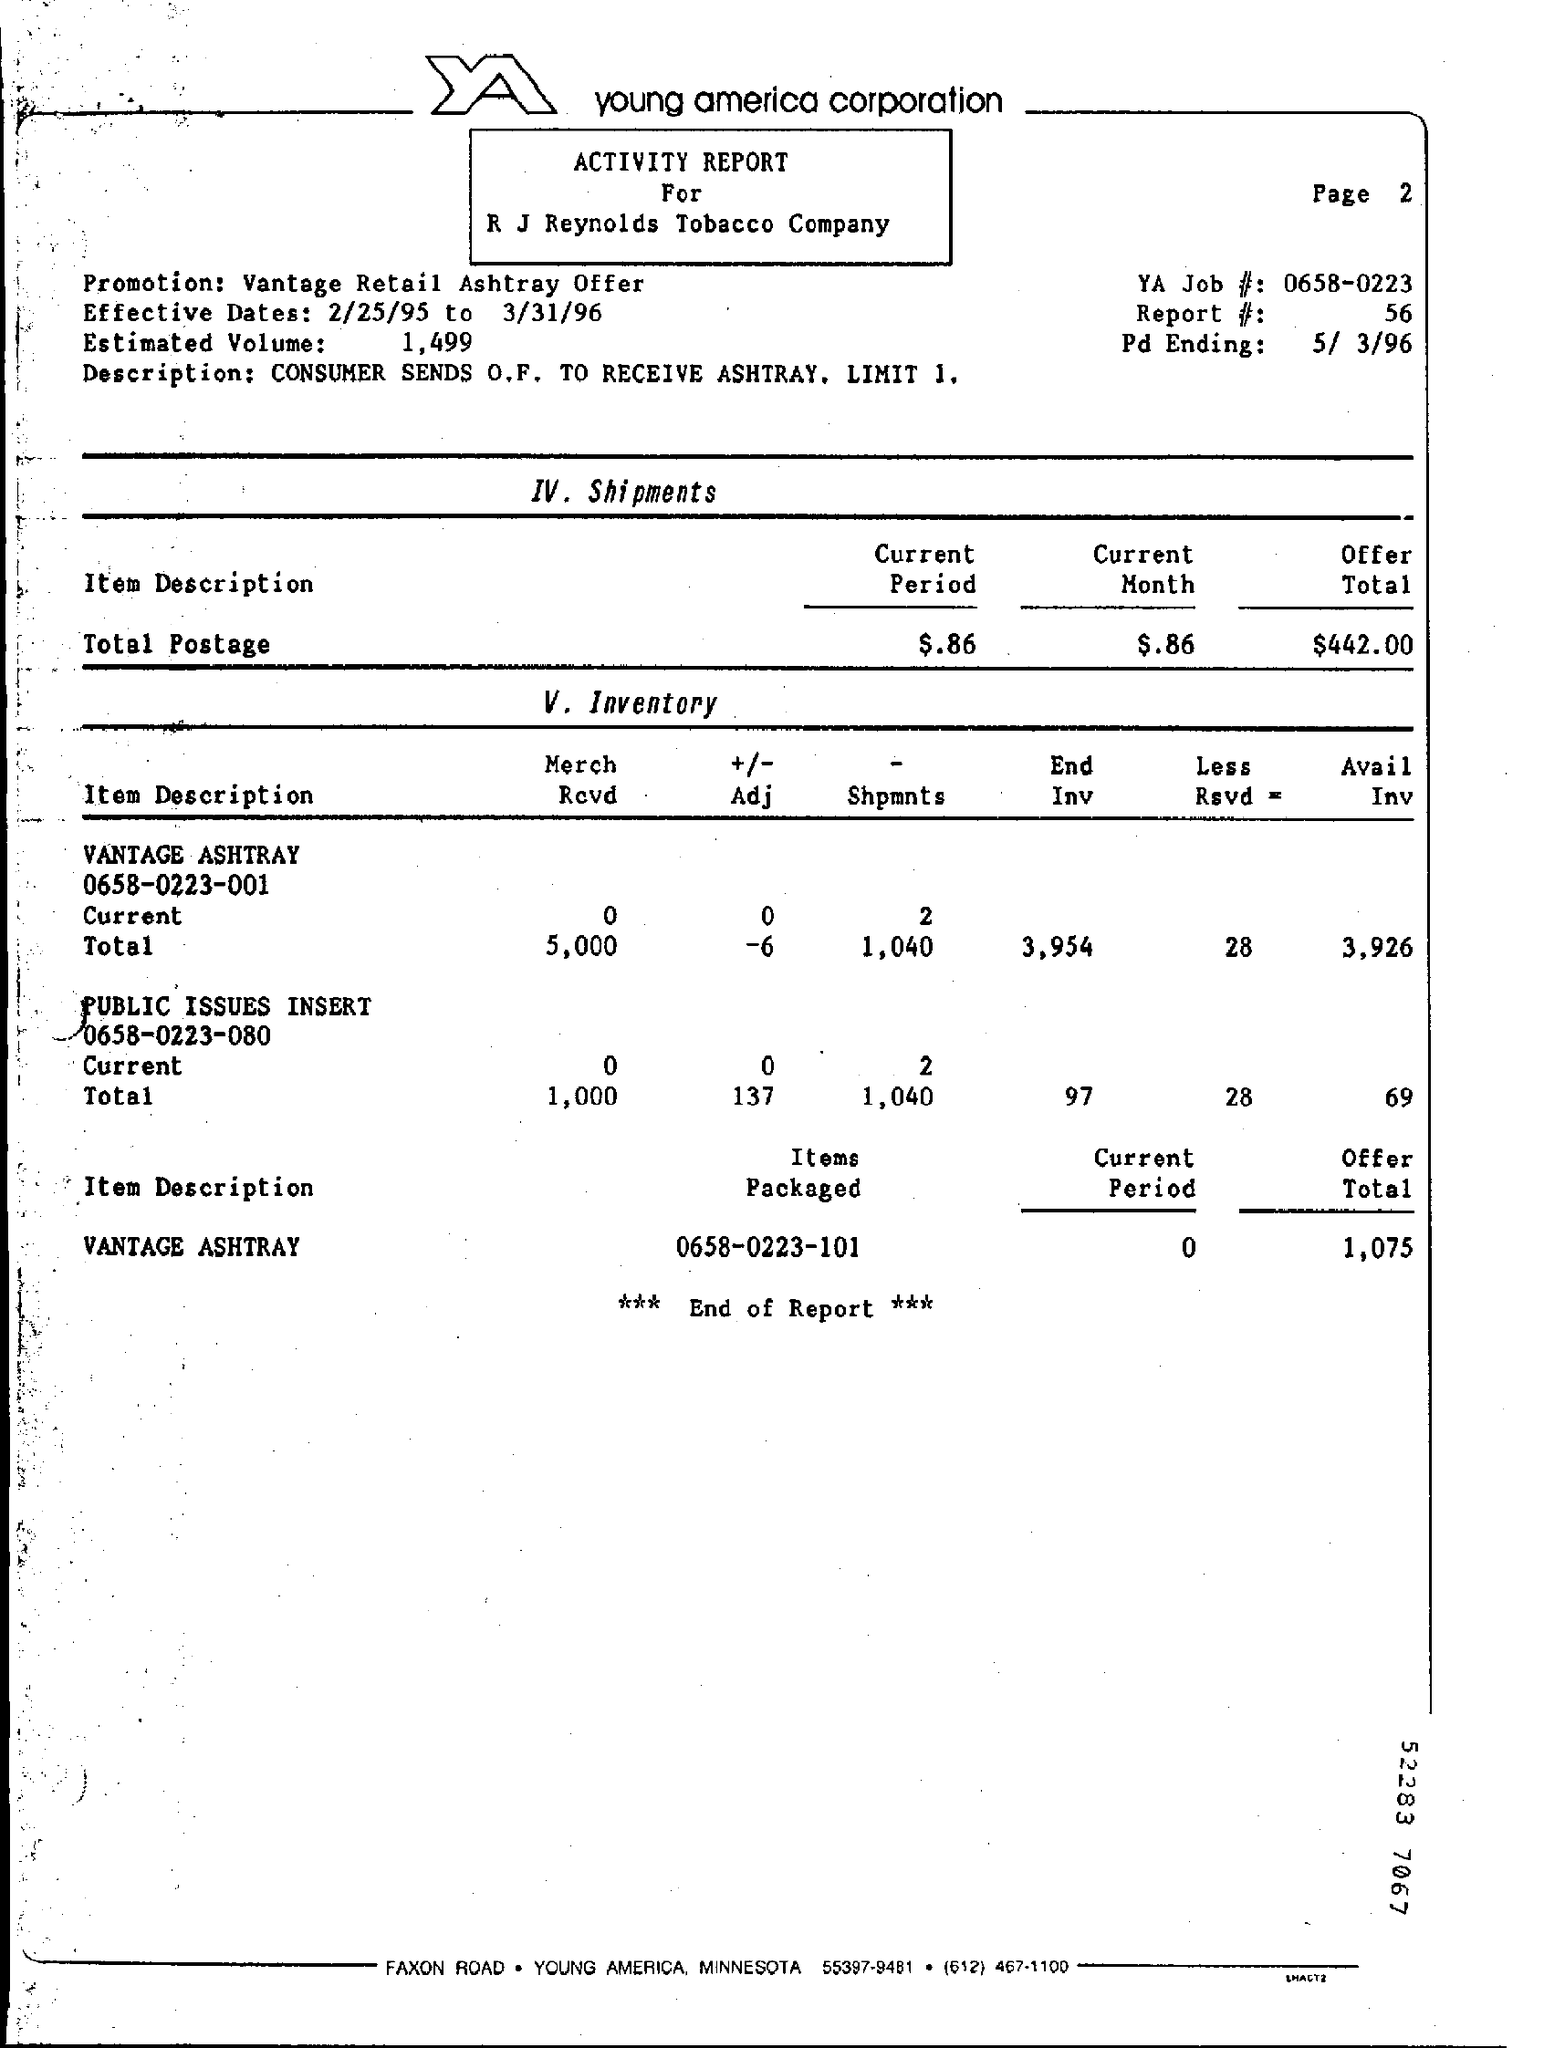What are the effective dates?
Your response must be concise. 2/25/95 to 3/31/96. What is the YA Job #?
Provide a succinct answer. 0658-0223. What is the report #?
Make the answer very short. 56. 